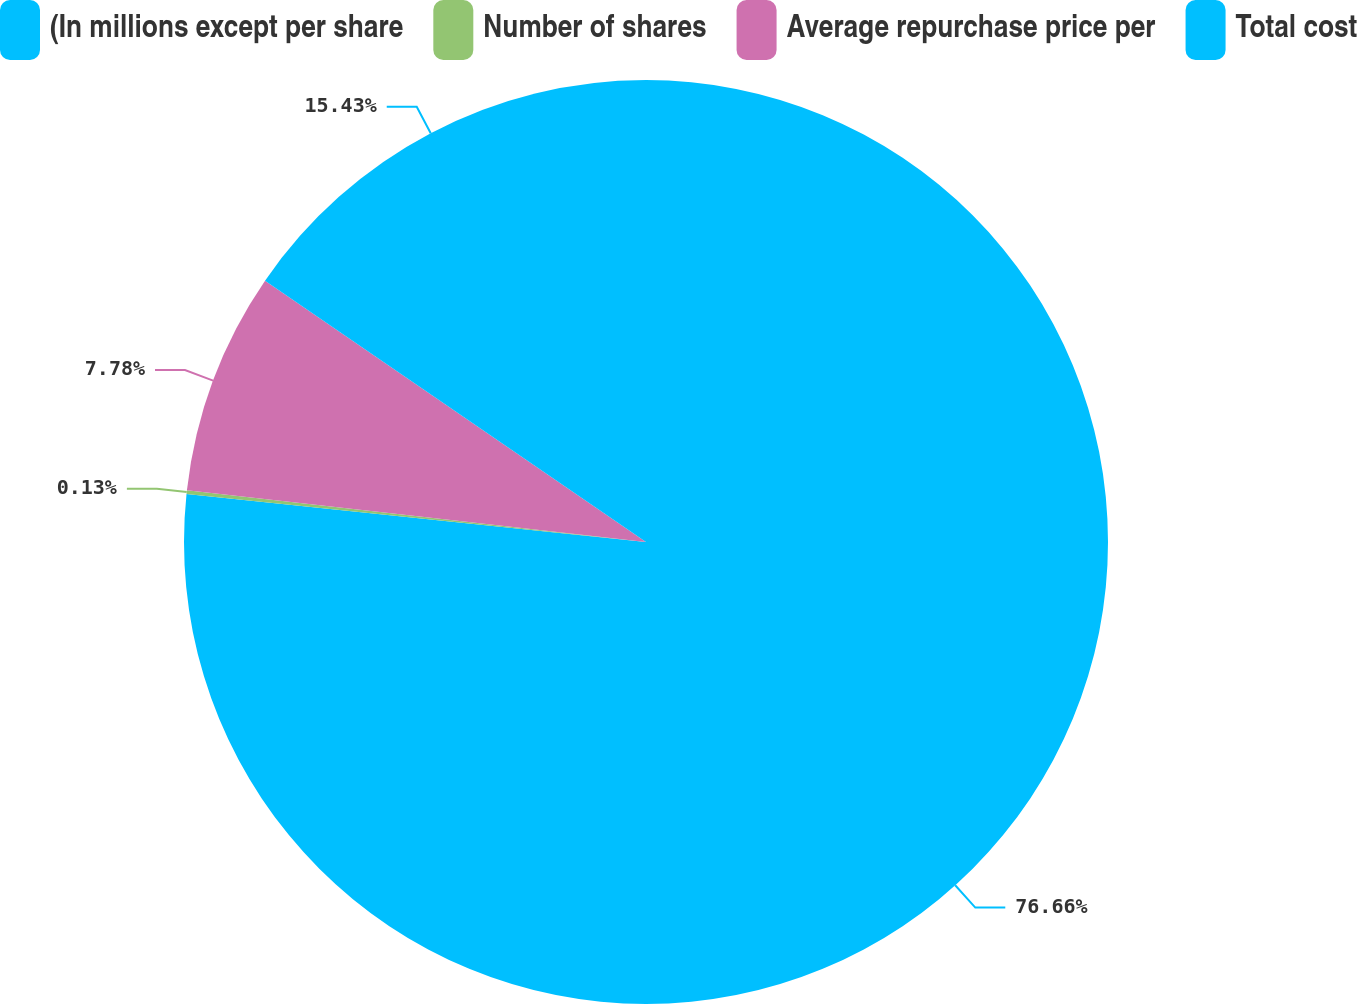Convert chart to OTSL. <chart><loc_0><loc_0><loc_500><loc_500><pie_chart><fcel>(In millions except per share<fcel>Number of shares<fcel>Average repurchase price per<fcel>Total cost<nl><fcel>76.66%<fcel>0.13%<fcel>7.78%<fcel>15.43%<nl></chart> 